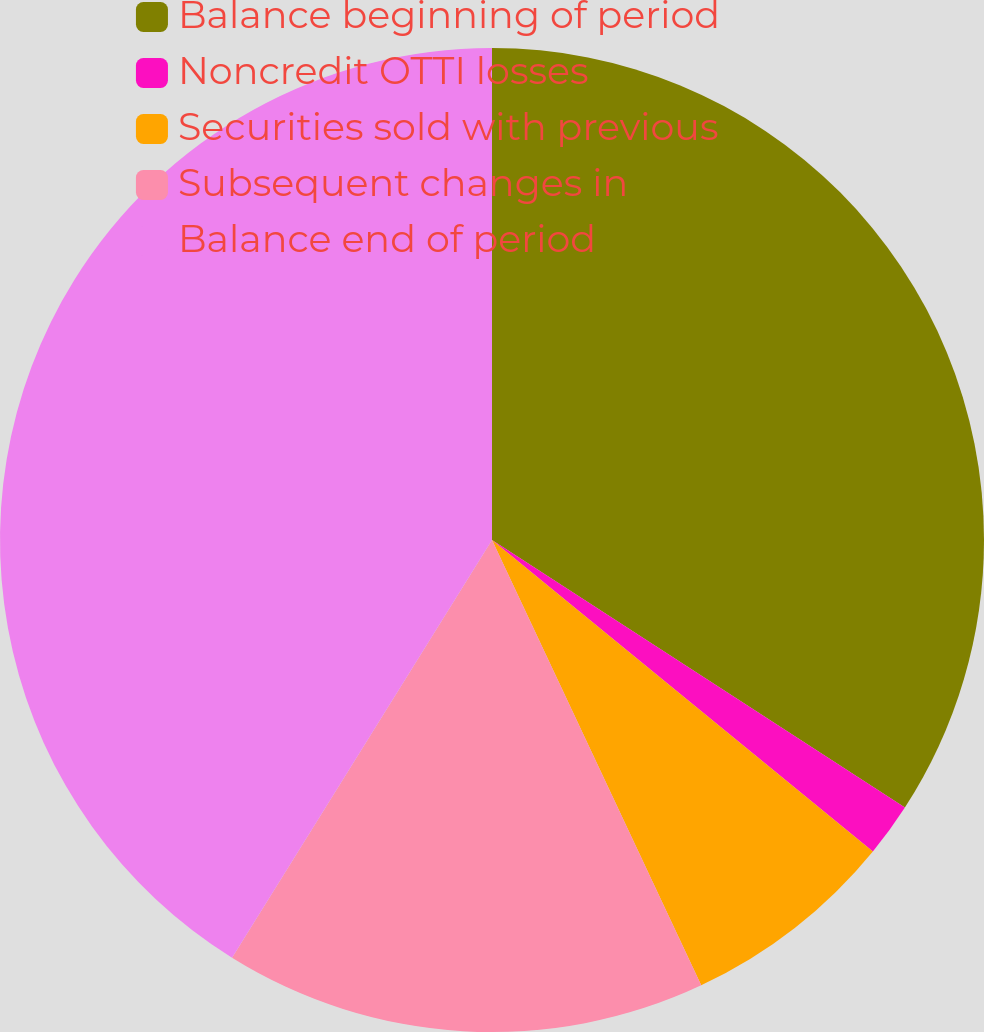Convert chart to OTSL. <chart><loc_0><loc_0><loc_500><loc_500><pie_chart><fcel>Balance beginning of period<fcel>Noncredit OTTI losses<fcel>Securities sold with previous<fcel>Subsequent changes in<fcel>Balance end of period<nl><fcel>34.15%<fcel>1.76%<fcel>7.1%<fcel>15.85%<fcel>41.14%<nl></chart> 